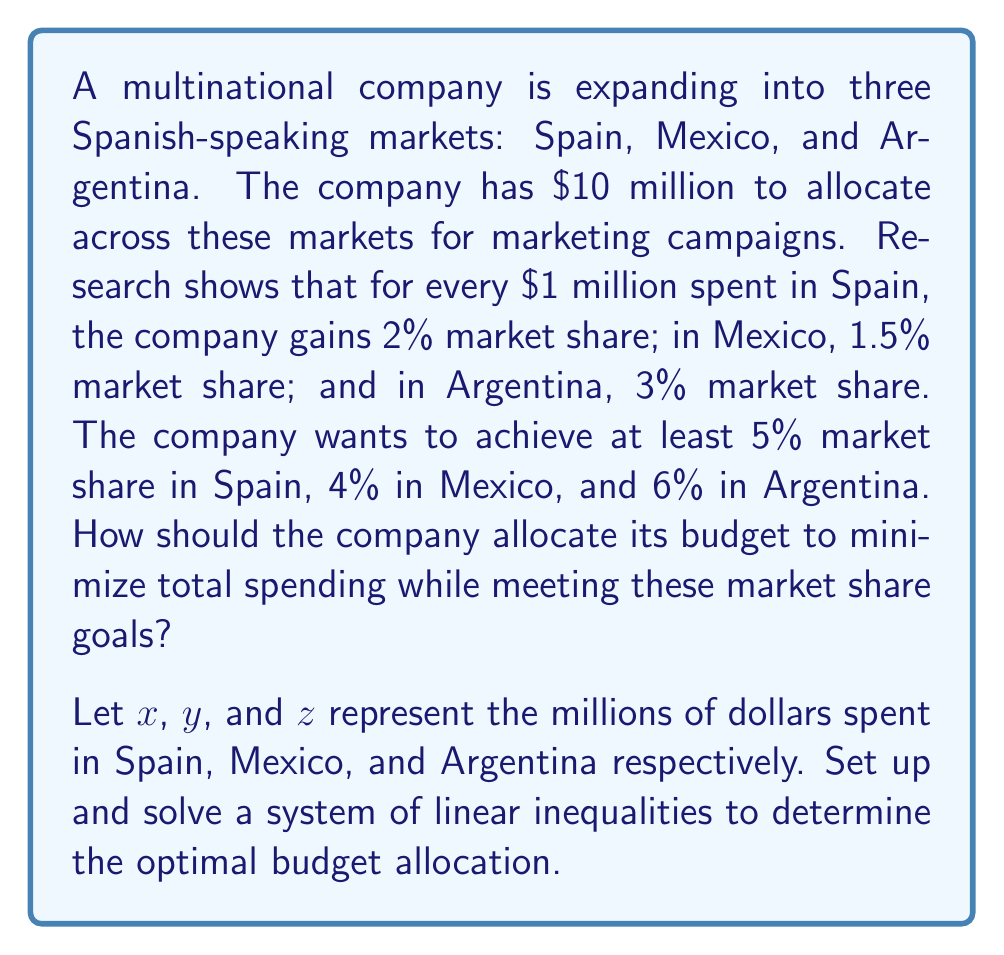What is the answer to this math problem? To solve this problem, we need to set up a system of linear inequalities and then minimize the total spending. Let's break it down step by step:

1. Set up the inequalities:
   For Spain: $2x \geq 5$ (2% share per million, at least 5% needed)
   For Mexico: $1.5y \geq 4$ (1.5% share per million, at least 4% needed)
   For Argentina: $3z \geq 6$ (3% share per million, at least 6% needed)

2. Add the constraint for total budget:
   $x + y + z \leq 10$ (total budget is $10 million)

3. Non-negativity constraints:
   $x \geq 0$, $y \geq 0$, $z \geq 0$

4. Our objective is to minimize $x + y + z$

5. Solve the inequalities:
   From Spain: $x \geq 2.5$
   From Mexico: $y \geq 2.67$
   From Argentina: $z \geq 2$

6. The minimum values that satisfy these inequalities are:
   $x = 2.5$, $y = 2.67$, $z = 2$

7. Check if this solution satisfies the total budget constraint:
   $2.5 + 2.67 + 2 = 7.17 < 10$, so it does.

8. Since we want to minimize spending, and this solution meets all constraints with the least possible values, it is the optimal solution.

Therefore, the optimal budget allocation is:
Spain: $2.5 million
Mexico: $2.67 million
Argentina: $2 million

Total spending: $7.17 million
Answer: The optimal budget allocation is:
Spain: $2.5 million
Mexico: $2.67 million
Argentina: $2 million
Total spending: $7.17 million 